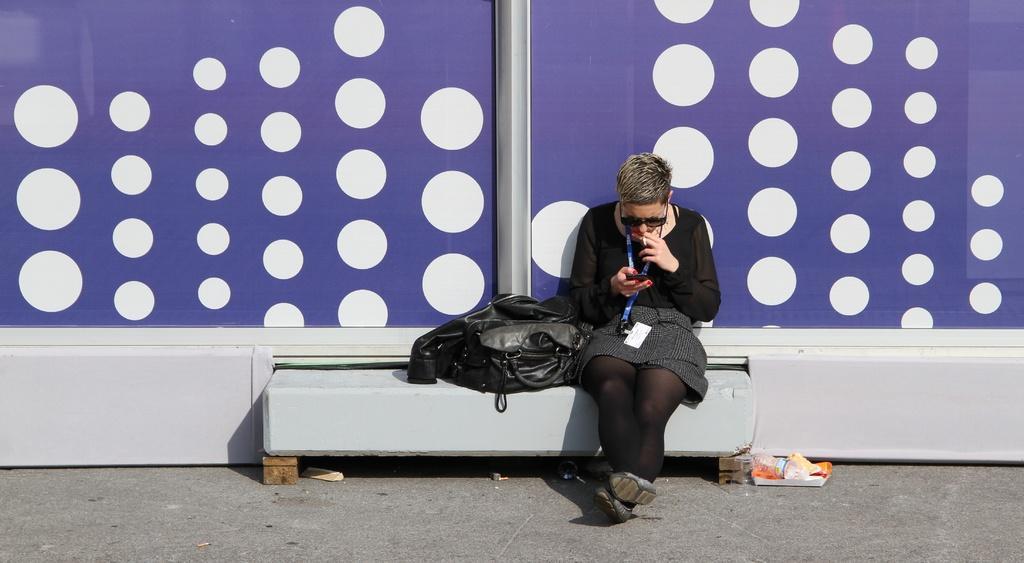Could you give a brief overview of what you see in this image? This picture is taken from outside the city. In this image, in the middle, we can see a woman wearing a black color dress is sitting on the bench and she is also having cigar in her hand. On the bench, we can also see a black color bag. In the background, we can see a blue color wall with color dots, at the bottom, we can see a book, on the book, we can see a water bottle and a land. 